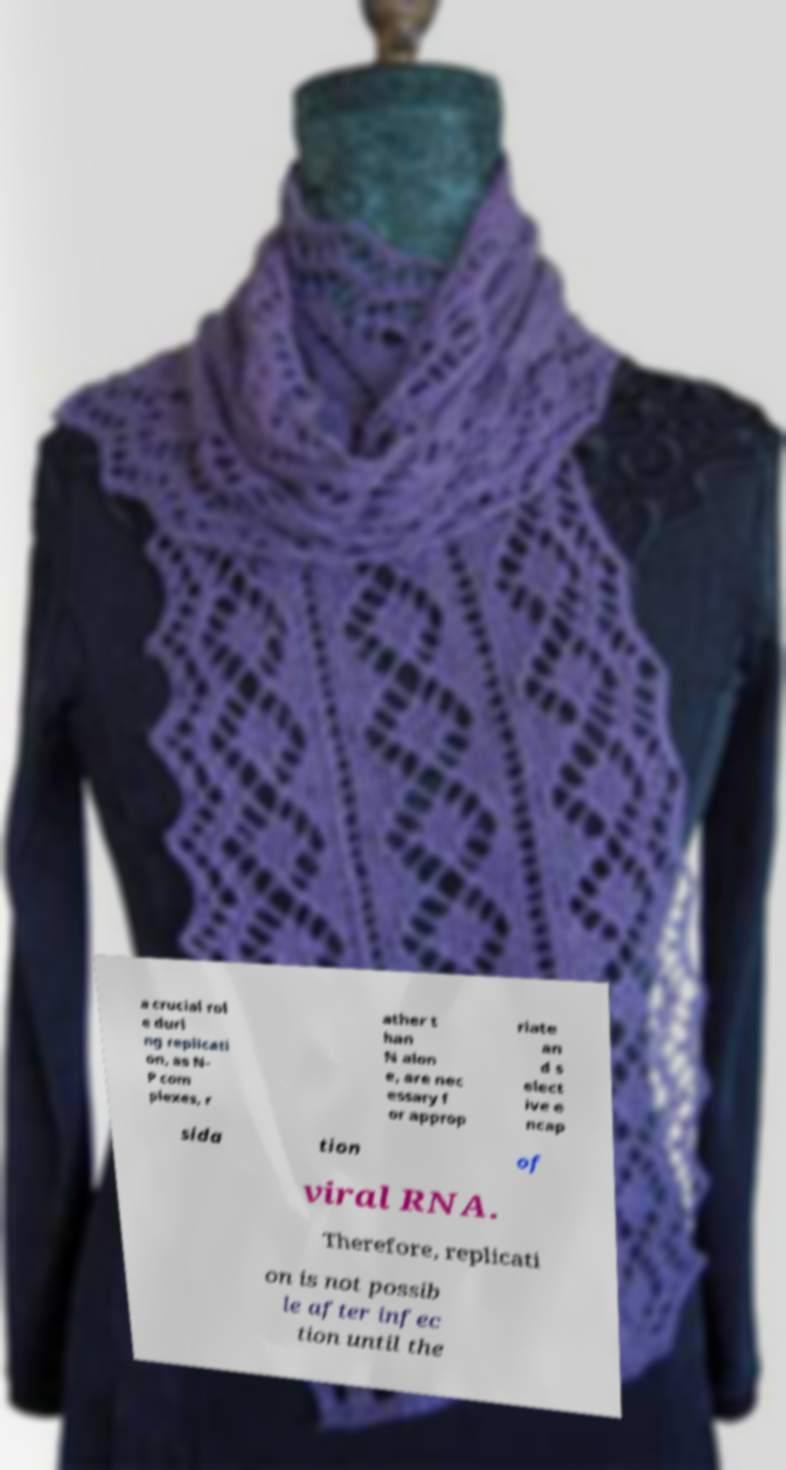Can you accurately transcribe the text from the provided image for me? a crucial rol e duri ng replicati on, as N- P com plexes, r ather t han N alon e, are nec essary f or approp riate an d s elect ive e ncap sida tion of viral RNA. Therefore, replicati on is not possib le after infec tion until the 